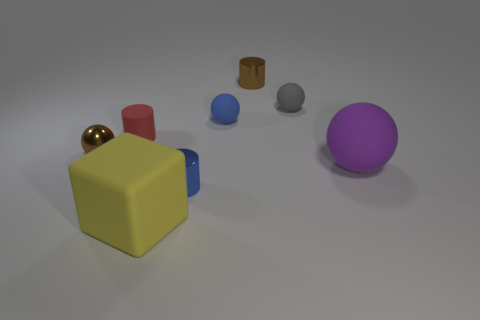Add 7 tiny rubber cylinders. How many tiny rubber cylinders are left? 8 Add 3 tiny spheres. How many tiny spheres exist? 6 Add 1 cyan rubber blocks. How many objects exist? 9 Subtract all purple spheres. How many spheres are left? 3 Subtract all small metallic cylinders. How many cylinders are left? 1 Subtract 1 brown balls. How many objects are left? 7 Subtract all cylinders. How many objects are left? 5 Subtract 1 cubes. How many cubes are left? 0 Subtract all blue spheres. Subtract all cyan cubes. How many spheres are left? 3 Subtract all green blocks. How many green balls are left? 0 